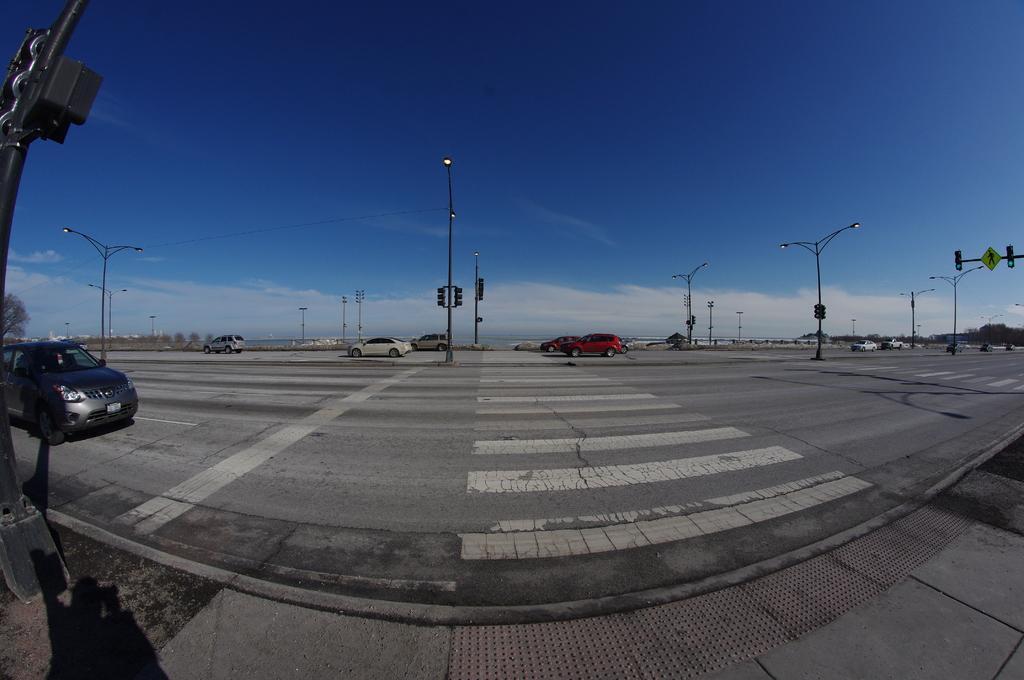Can you describe this image briefly? At the bottom of the picture, we see the road. Here, we see many vehicles moving on the road. There are many street lights and traffic signals. On the right side, we see the traffic signal and a board in green color. On the left side, we see a black pole. There are trees and buildings in the background. At the top, we see the sky, which is blue in color. 